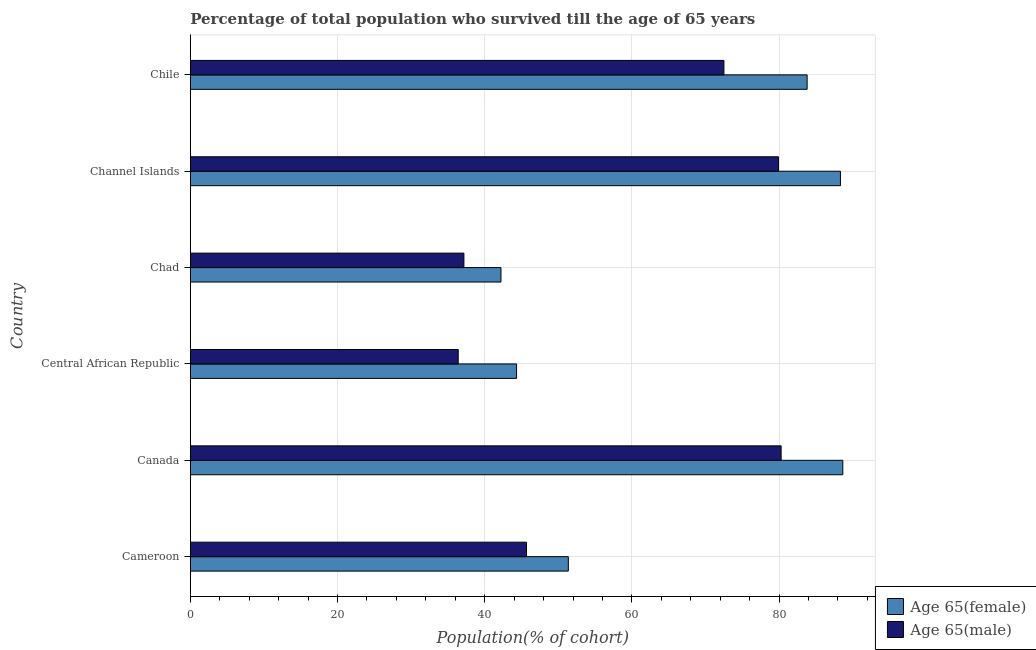Are the number of bars per tick equal to the number of legend labels?
Offer a very short reply. Yes. How many bars are there on the 1st tick from the bottom?
Your answer should be very brief. 2. What is the label of the 4th group of bars from the top?
Keep it short and to the point. Central African Republic. In how many cases, is the number of bars for a given country not equal to the number of legend labels?
Give a very brief answer. 0. What is the percentage of female population who survived till age of 65 in Cameroon?
Your answer should be compact. 51.37. Across all countries, what is the maximum percentage of female population who survived till age of 65?
Provide a succinct answer. 88.66. Across all countries, what is the minimum percentage of male population who survived till age of 65?
Your answer should be very brief. 36.4. In which country was the percentage of male population who survived till age of 65 minimum?
Provide a short and direct response. Central African Republic. What is the total percentage of male population who survived till age of 65 in the graph?
Ensure brevity in your answer.  351.97. What is the difference between the percentage of female population who survived till age of 65 in Canada and that in Channel Islands?
Make the answer very short. 0.32. What is the difference between the percentage of male population who survived till age of 65 in Central African Republic and the percentage of female population who survived till age of 65 in Chile?
Provide a short and direct response. -47.41. What is the average percentage of male population who survived till age of 65 per country?
Your response must be concise. 58.66. What is the difference between the percentage of female population who survived till age of 65 and percentage of male population who survived till age of 65 in Canada?
Keep it short and to the point. 8.38. What is the ratio of the percentage of male population who survived till age of 65 in Cameroon to that in Chad?
Offer a terse response. 1.23. Is the percentage of female population who survived till age of 65 in Canada less than that in Channel Islands?
Offer a very short reply. No. What is the difference between the highest and the second highest percentage of male population who survived till age of 65?
Make the answer very short. 0.36. What is the difference between the highest and the lowest percentage of female population who survived till age of 65?
Offer a very short reply. 46.45. In how many countries, is the percentage of female population who survived till age of 65 greater than the average percentage of female population who survived till age of 65 taken over all countries?
Your answer should be compact. 3. What does the 1st bar from the top in Channel Islands represents?
Your answer should be very brief. Age 65(male). What does the 2nd bar from the bottom in Canada represents?
Ensure brevity in your answer.  Age 65(male). How many bars are there?
Ensure brevity in your answer.  12. Are all the bars in the graph horizontal?
Keep it short and to the point. Yes. How many countries are there in the graph?
Ensure brevity in your answer.  6. What is the difference between two consecutive major ticks on the X-axis?
Ensure brevity in your answer.  20. Are the values on the major ticks of X-axis written in scientific E-notation?
Your answer should be very brief. No. Does the graph contain grids?
Give a very brief answer. Yes. How are the legend labels stacked?
Make the answer very short. Vertical. What is the title of the graph?
Your response must be concise. Percentage of total population who survived till the age of 65 years. Does "Forest land" appear as one of the legend labels in the graph?
Keep it short and to the point. No. What is the label or title of the X-axis?
Make the answer very short. Population(% of cohort). What is the Population(% of cohort) in Age 65(female) in Cameroon?
Your answer should be compact. 51.37. What is the Population(% of cohort) of Age 65(male) in Cameroon?
Give a very brief answer. 45.68. What is the Population(% of cohort) in Age 65(female) in Canada?
Your answer should be very brief. 88.66. What is the Population(% of cohort) in Age 65(male) in Canada?
Your answer should be compact. 80.28. What is the Population(% of cohort) of Age 65(female) in Central African Republic?
Provide a succinct answer. 44.33. What is the Population(% of cohort) of Age 65(male) in Central African Republic?
Offer a terse response. 36.4. What is the Population(% of cohort) in Age 65(female) in Chad?
Keep it short and to the point. 42.21. What is the Population(% of cohort) of Age 65(male) in Chad?
Offer a terse response. 37.18. What is the Population(% of cohort) of Age 65(female) in Channel Islands?
Your answer should be compact. 88.34. What is the Population(% of cohort) in Age 65(male) in Channel Islands?
Offer a very short reply. 79.92. What is the Population(% of cohort) in Age 65(female) in Chile?
Provide a succinct answer. 83.81. What is the Population(% of cohort) of Age 65(male) in Chile?
Your response must be concise. 72.51. Across all countries, what is the maximum Population(% of cohort) in Age 65(female)?
Make the answer very short. 88.66. Across all countries, what is the maximum Population(% of cohort) of Age 65(male)?
Provide a short and direct response. 80.28. Across all countries, what is the minimum Population(% of cohort) in Age 65(female)?
Offer a very short reply. 42.21. Across all countries, what is the minimum Population(% of cohort) in Age 65(male)?
Provide a short and direct response. 36.4. What is the total Population(% of cohort) in Age 65(female) in the graph?
Give a very brief answer. 398.73. What is the total Population(% of cohort) in Age 65(male) in the graph?
Your response must be concise. 351.97. What is the difference between the Population(% of cohort) of Age 65(female) in Cameroon and that in Canada?
Your response must be concise. -37.29. What is the difference between the Population(% of cohort) in Age 65(male) in Cameroon and that in Canada?
Make the answer very short. -34.6. What is the difference between the Population(% of cohort) of Age 65(female) in Cameroon and that in Central African Republic?
Make the answer very short. 7.03. What is the difference between the Population(% of cohort) of Age 65(male) in Cameroon and that in Central African Republic?
Make the answer very short. 9.28. What is the difference between the Population(% of cohort) in Age 65(female) in Cameroon and that in Chad?
Offer a terse response. 9.15. What is the difference between the Population(% of cohort) in Age 65(male) in Cameroon and that in Chad?
Keep it short and to the point. 8.51. What is the difference between the Population(% of cohort) of Age 65(female) in Cameroon and that in Channel Islands?
Provide a short and direct response. -36.97. What is the difference between the Population(% of cohort) of Age 65(male) in Cameroon and that in Channel Islands?
Your answer should be compact. -34.23. What is the difference between the Population(% of cohort) of Age 65(female) in Cameroon and that in Chile?
Your answer should be very brief. -32.45. What is the difference between the Population(% of cohort) of Age 65(male) in Cameroon and that in Chile?
Your response must be concise. -26.82. What is the difference between the Population(% of cohort) in Age 65(female) in Canada and that in Central African Republic?
Your response must be concise. 44.33. What is the difference between the Population(% of cohort) in Age 65(male) in Canada and that in Central African Republic?
Make the answer very short. 43.88. What is the difference between the Population(% of cohort) in Age 65(female) in Canada and that in Chad?
Give a very brief answer. 46.45. What is the difference between the Population(% of cohort) of Age 65(male) in Canada and that in Chad?
Give a very brief answer. 43.1. What is the difference between the Population(% of cohort) in Age 65(female) in Canada and that in Channel Islands?
Your response must be concise. 0.32. What is the difference between the Population(% of cohort) in Age 65(male) in Canada and that in Channel Islands?
Your answer should be compact. 0.36. What is the difference between the Population(% of cohort) in Age 65(female) in Canada and that in Chile?
Ensure brevity in your answer.  4.85. What is the difference between the Population(% of cohort) in Age 65(male) in Canada and that in Chile?
Keep it short and to the point. 7.77. What is the difference between the Population(% of cohort) of Age 65(female) in Central African Republic and that in Chad?
Your answer should be very brief. 2.12. What is the difference between the Population(% of cohort) of Age 65(male) in Central African Republic and that in Chad?
Provide a short and direct response. -0.77. What is the difference between the Population(% of cohort) in Age 65(female) in Central African Republic and that in Channel Islands?
Your answer should be compact. -44. What is the difference between the Population(% of cohort) of Age 65(male) in Central African Republic and that in Channel Islands?
Keep it short and to the point. -43.51. What is the difference between the Population(% of cohort) of Age 65(female) in Central African Republic and that in Chile?
Your response must be concise. -39.48. What is the difference between the Population(% of cohort) of Age 65(male) in Central African Republic and that in Chile?
Your answer should be compact. -36.1. What is the difference between the Population(% of cohort) of Age 65(female) in Chad and that in Channel Islands?
Ensure brevity in your answer.  -46.13. What is the difference between the Population(% of cohort) in Age 65(male) in Chad and that in Channel Islands?
Make the answer very short. -42.74. What is the difference between the Population(% of cohort) in Age 65(female) in Chad and that in Chile?
Your response must be concise. -41.6. What is the difference between the Population(% of cohort) of Age 65(male) in Chad and that in Chile?
Offer a very short reply. -35.33. What is the difference between the Population(% of cohort) in Age 65(female) in Channel Islands and that in Chile?
Keep it short and to the point. 4.53. What is the difference between the Population(% of cohort) in Age 65(male) in Channel Islands and that in Chile?
Your answer should be compact. 7.41. What is the difference between the Population(% of cohort) in Age 65(female) in Cameroon and the Population(% of cohort) in Age 65(male) in Canada?
Give a very brief answer. -28.91. What is the difference between the Population(% of cohort) of Age 65(female) in Cameroon and the Population(% of cohort) of Age 65(male) in Central African Republic?
Your response must be concise. 14.96. What is the difference between the Population(% of cohort) of Age 65(female) in Cameroon and the Population(% of cohort) of Age 65(male) in Chad?
Your answer should be compact. 14.19. What is the difference between the Population(% of cohort) in Age 65(female) in Cameroon and the Population(% of cohort) in Age 65(male) in Channel Islands?
Keep it short and to the point. -28.55. What is the difference between the Population(% of cohort) in Age 65(female) in Cameroon and the Population(% of cohort) in Age 65(male) in Chile?
Your response must be concise. -21.14. What is the difference between the Population(% of cohort) in Age 65(female) in Canada and the Population(% of cohort) in Age 65(male) in Central African Republic?
Provide a short and direct response. 52.26. What is the difference between the Population(% of cohort) in Age 65(female) in Canada and the Population(% of cohort) in Age 65(male) in Chad?
Ensure brevity in your answer.  51.48. What is the difference between the Population(% of cohort) of Age 65(female) in Canada and the Population(% of cohort) of Age 65(male) in Channel Islands?
Your response must be concise. 8.74. What is the difference between the Population(% of cohort) of Age 65(female) in Canada and the Population(% of cohort) of Age 65(male) in Chile?
Give a very brief answer. 16.15. What is the difference between the Population(% of cohort) of Age 65(female) in Central African Republic and the Population(% of cohort) of Age 65(male) in Chad?
Provide a short and direct response. 7.16. What is the difference between the Population(% of cohort) in Age 65(female) in Central African Republic and the Population(% of cohort) in Age 65(male) in Channel Islands?
Give a very brief answer. -35.58. What is the difference between the Population(% of cohort) of Age 65(female) in Central African Republic and the Population(% of cohort) of Age 65(male) in Chile?
Provide a succinct answer. -28.17. What is the difference between the Population(% of cohort) of Age 65(female) in Chad and the Population(% of cohort) of Age 65(male) in Channel Islands?
Offer a very short reply. -37.7. What is the difference between the Population(% of cohort) of Age 65(female) in Chad and the Population(% of cohort) of Age 65(male) in Chile?
Offer a terse response. -30.29. What is the difference between the Population(% of cohort) of Age 65(female) in Channel Islands and the Population(% of cohort) of Age 65(male) in Chile?
Your answer should be compact. 15.83. What is the average Population(% of cohort) in Age 65(female) per country?
Offer a very short reply. 66.45. What is the average Population(% of cohort) of Age 65(male) per country?
Offer a terse response. 58.66. What is the difference between the Population(% of cohort) in Age 65(female) and Population(% of cohort) in Age 65(male) in Cameroon?
Provide a succinct answer. 5.68. What is the difference between the Population(% of cohort) in Age 65(female) and Population(% of cohort) in Age 65(male) in Canada?
Your response must be concise. 8.38. What is the difference between the Population(% of cohort) in Age 65(female) and Population(% of cohort) in Age 65(male) in Central African Republic?
Your response must be concise. 7.93. What is the difference between the Population(% of cohort) of Age 65(female) and Population(% of cohort) of Age 65(male) in Chad?
Provide a succinct answer. 5.04. What is the difference between the Population(% of cohort) of Age 65(female) and Population(% of cohort) of Age 65(male) in Channel Islands?
Your answer should be very brief. 8.42. What is the difference between the Population(% of cohort) in Age 65(female) and Population(% of cohort) in Age 65(male) in Chile?
Make the answer very short. 11.3. What is the ratio of the Population(% of cohort) of Age 65(female) in Cameroon to that in Canada?
Make the answer very short. 0.58. What is the ratio of the Population(% of cohort) of Age 65(male) in Cameroon to that in Canada?
Give a very brief answer. 0.57. What is the ratio of the Population(% of cohort) of Age 65(female) in Cameroon to that in Central African Republic?
Your response must be concise. 1.16. What is the ratio of the Population(% of cohort) of Age 65(male) in Cameroon to that in Central African Republic?
Provide a succinct answer. 1.25. What is the ratio of the Population(% of cohort) in Age 65(female) in Cameroon to that in Chad?
Provide a succinct answer. 1.22. What is the ratio of the Population(% of cohort) in Age 65(male) in Cameroon to that in Chad?
Offer a terse response. 1.23. What is the ratio of the Population(% of cohort) of Age 65(female) in Cameroon to that in Channel Islands?
Your response must be concise. 0.58. What is the ratio of the Population(% of cohort) in Age 65(male) in Cameroon to that in Channel Islands?
Ensure brevity in your answer.  0.57. What is the ratio of the Population(% of cohort) in Age 65(female) in Cameroon to that in Chile?
Your answer should be compact. 0.61. What is the ratio of the Population(% of cohort) in Age 65(male) in Cameroon to that in Chile?
Your answer should be very brief. 0.63. What is the ratio of the Population(% of cohort) in Age 65(female) in Canada to that in Central African Republic?
Keep it short and to the point. 2. What is the ratio of the Population(% of cohort) in Age 65(male) in Canada to that in Central African Republic?
Your answer should be compact. 2.21. What is the ratio of the Population(% of cohort) of Age 65(female) in Canada to that in Chad?
Keep it short and to the point. 2.1. What is the ratio of the Population(% of cohort) in Age 65(male) in Canada to that in Chad?
Offer a very short reply. 2.16. What is the ratio of the Population(% of cohort) in Age 65(female) in Canada to that in Channel Islands?
Your answer should be compact. 1. What is the ratio of the Population(% of cohort) of Age 65(male) in Canada to that in Channel Islands?
Make the answer very short. 1. What is the ratio of the Population(% of cohort) of Age 65(female) in Canada to that in Chile?
Your answer should be very brief. 1.06. What is the ratio of the Population(% of cohort) of Age 65(male) in Canada to that in Chile?
Provide a succinct answer. 1.11. What is the ratio of the Population(% of cohort) in Age 65(female) in Central African Republic to that in Chad?
Ensure brevity in your answer.  1.05. What is the ratio of the Population(% of cohort) of Age 65(male) in Central African Republic to that in Chad?
Keep it short and to the point. 0.98. What is the ratio of the Population(% of cohort) of Age 65(female) in Central African Republic to that in Channel Islands?
Keep it short and to the point. 0.5. What is the ratio of the Population(% of cohort) of Age 65(male) in Central African Republic to that in Channel Islands?
Keep it short and to the point. 0.46. What is the ratio of the Population(% of cohort) in Age 65(female) in Central African Republic to that in Chile?
Offer a terse response. 0.53. What is the ratio of the Population(% of cohort) in Age 65(male) in Central African Republic to that in Chile?
Your response must be concise. 0.5. What is the ratio of the Population(% of cohort) of Age 65(female) in Chad to that in Channel Islands?
Ensure brevity in your answer.  0.48. What is the ratio of the Population(% of cohort) in Age 65(male) in Chad to that in Channel Islands?
Keep it short and to the point. 0.47. What is the ratio of the Population(% of cohort) of Age 65(female) in Chad to that in Chile?
Ensure brevity in your answer.  0.5. What is the ratio of the Population(% of cohort) of Age 65(male) in Chad to that in Chile?
Your response must be concise. 0.51. What is the ratio of the Population(% of cohort) of Age 65(female) in Channel Islands to that in Chile?
Give a very brief answer. 1.05. What is the ratio of the Population(% of cohort) in Age 65(male) in Channel Islands to that in Chile?
Provide a short and direct response. 1.1. What is the difference between the highest and the second highest Population(% of cohort) of Age 65(female)?
Keep it short and to the point. 0.32. What is the difference between the highest and the second highest Population(% of cohort) of Age 65(male)?
Ensure brevity in your answer.  0.36. What is the difference between the highest and the lowest Population(% of cohort) in Age 65(female)?
Ensure brevity in your answer.  46.45. What is the difference between the highest and the lowest Population(% of cohort) in Age 65(male)?
Your answer should be compact. 43.88. 